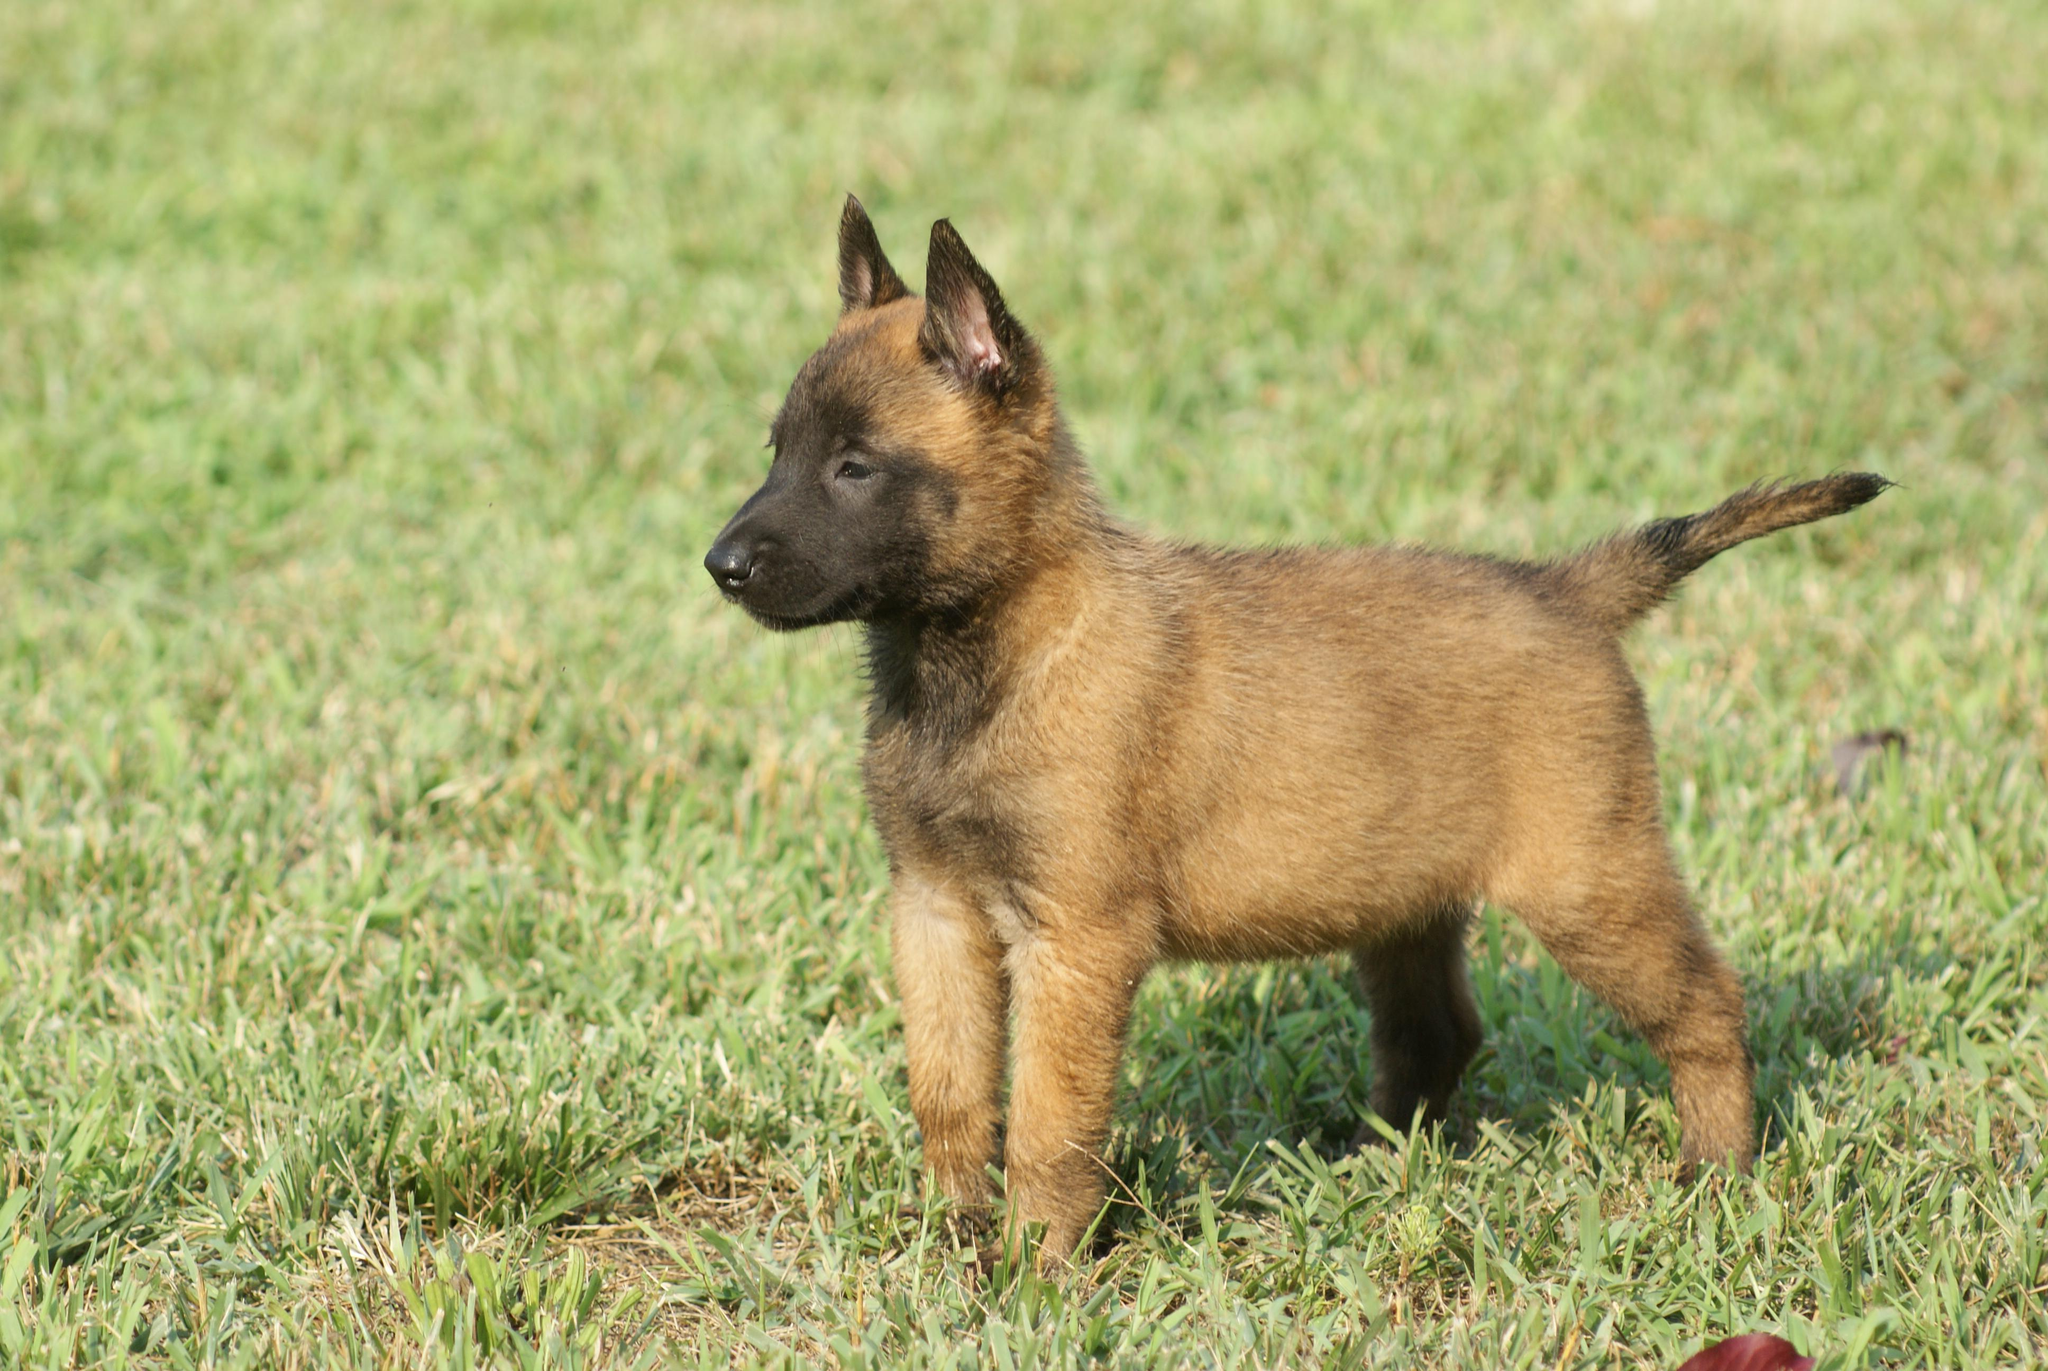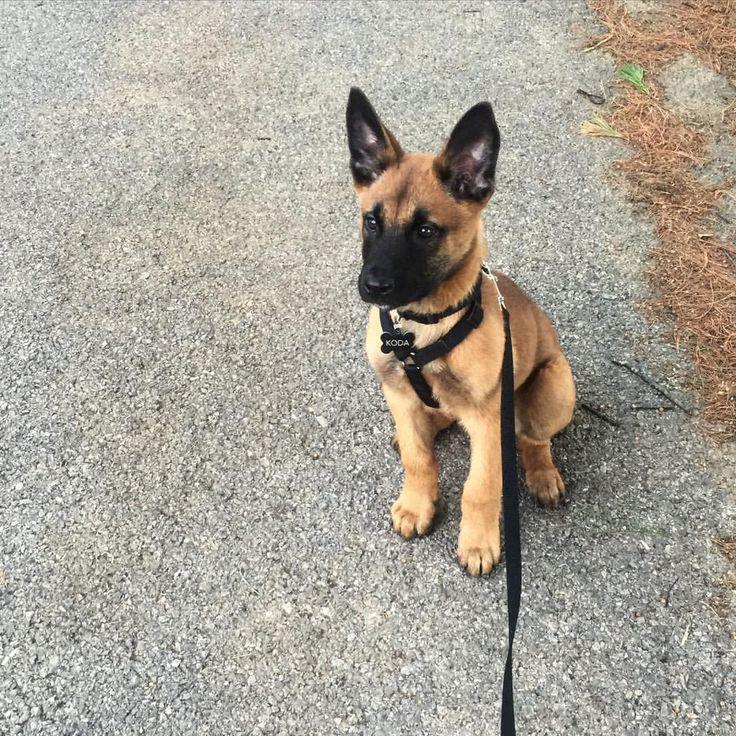The first image is the image on the left, the second image is the image on the right. Analyze the images presented: Is the assertion "At least one dog is wearing a leash." valid? Answer yes or no. Yes. The first image is the image on the left, the second image is the image on the right. Assess this claim about the two images: "A puppy is running through the grass toward the camera.". Correct or not? Answer yes or no. No. 